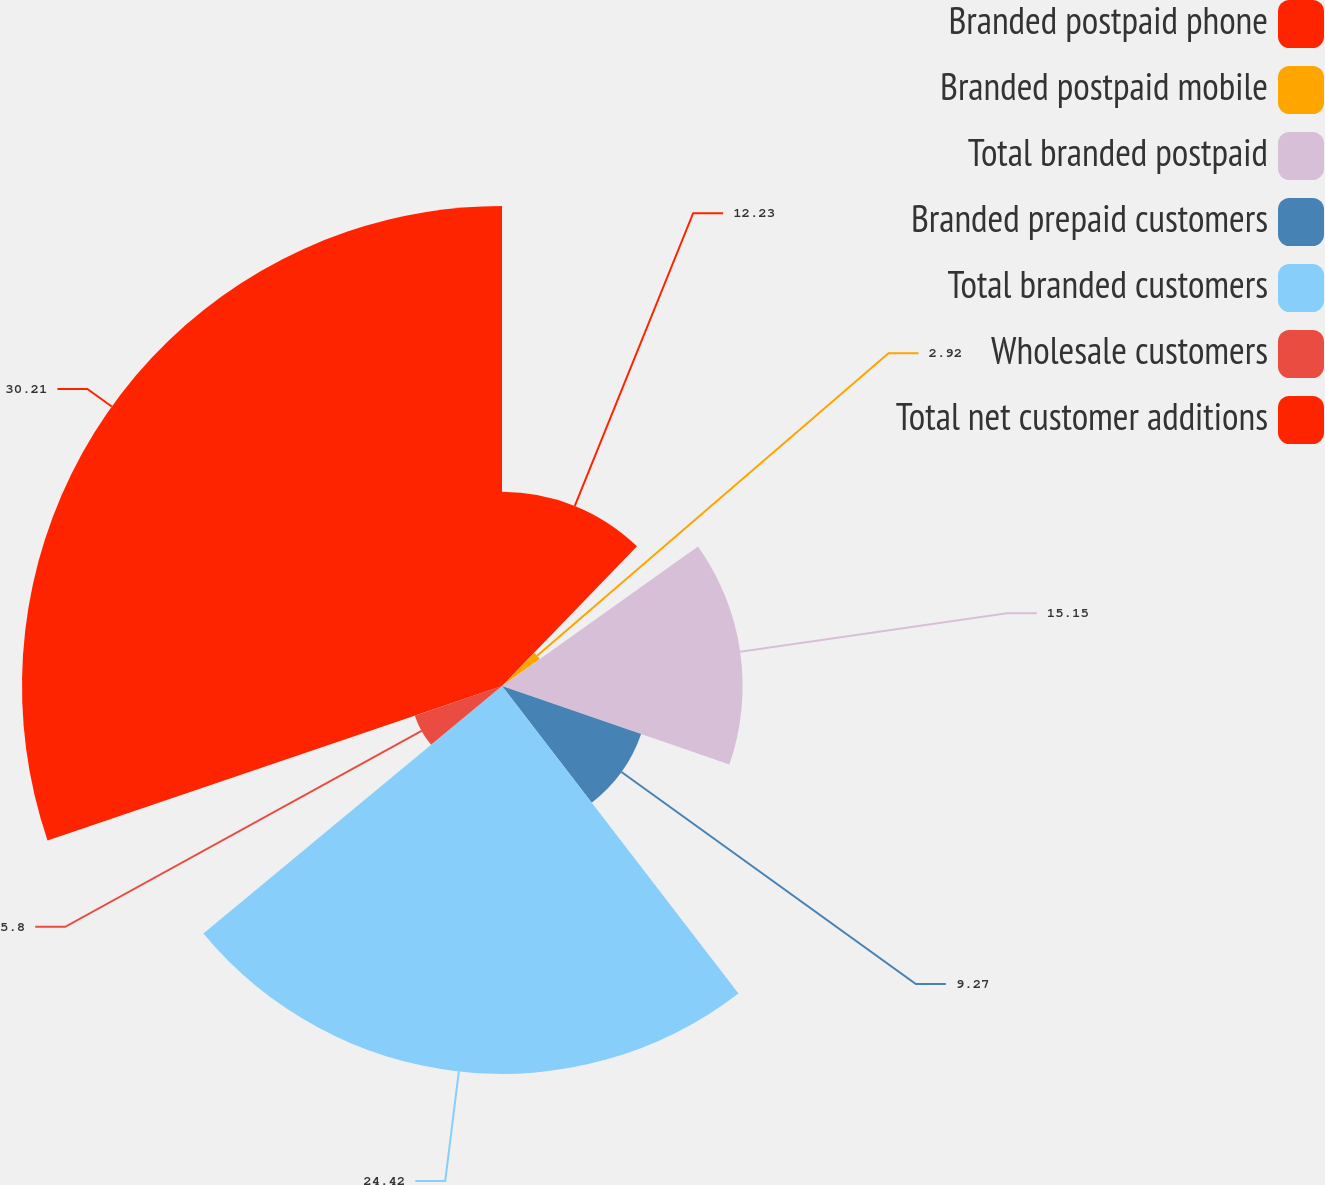Convert chart to OTSL. <chart><loc_0><loc_0><loc_500><loc_500><pie_chart><fcel>Branded postpaid phone<fcel>Branded postpaid mobile<fcel>Total branded postpaid<fcel>Branded prepaid customers<fcel>Total branded customers<fcel>Wholesale customers<fcel>Total net customer additions<nl><fcel>12.23%<fcel>2.92%<fcel>15.15%<fcel>9.27%<fcel>24.42%<fcel>5.8%<fcel>30.22%<nl></chart> 